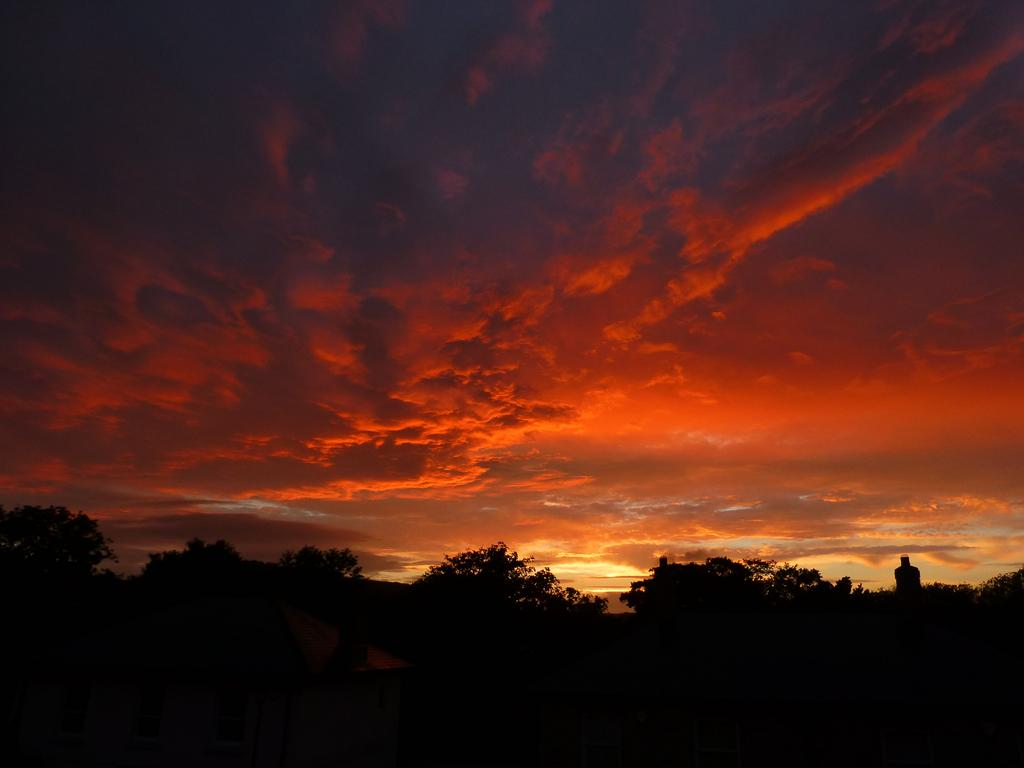What can be seen in the sky in the image? The sky is visible in the image, and clouds are present. What type of natural vegetation is in the image? Trees are in the image. What type of structure is in the image? There is a house in the image. What other objects can be seen in the image? There are a few other objects in the image. Can you tell me how many porters are carrying the spring in the image? There is no porter or spring present in the image. 